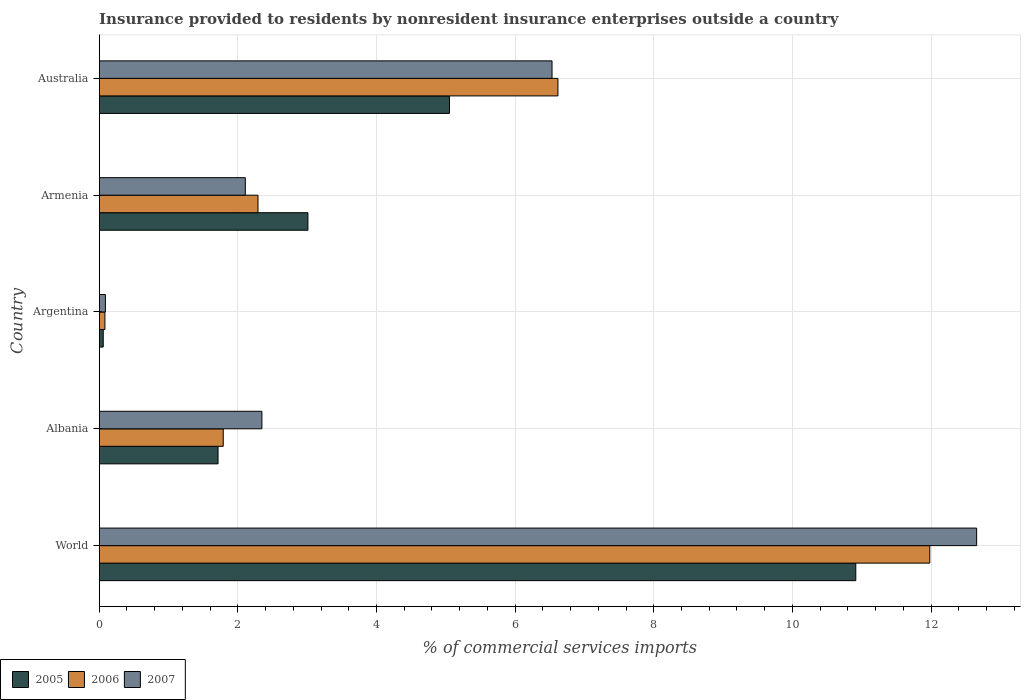How many bars are there on the 3rd tick from the bottom?
Ensure brevity in your answer.  3. What is the label of the 4th group of bars from the top?
Your answer should be compact. Albania. What is the Insurance provided to residents in 2005 in Albania?
Ensure brevity in your answer.  1.71. Across all countries, what is the maximum Insurance provided to residents in 2007?
Your response must be concise. 12.66. Across all countries, what is the minimum Insurance provided to residents in 2005?
Keep it short and to the point. 0.06. In which country was the Insurance provided to residents in 2005 maximum?
Provide a succinct answer. World. What is the total Insurance provided to residents in 2005 in the graph?
Your answer should be very brief. 20.75. What is the difference between the Insurance provided to residents in 2007 in Armenia and that in World?
Give a very brief answer. -10.55. What is the difference between the Insurance provided to residents in 2005 in Albania and the Insurance provided to residents in 2007 in World?
Provide a succinct answer. -10.94. What is the average Insurance provided to residents in 2005 per country?
Provide a succinct answer. 4.15. What is the difference between the Insurance provided to residents in 2005 and Insurance provided to residents in 2007 in Albania?
Provide a short and direct response. -0.63. In how many countries, is the Insurance provided to residents in 2007 greater than 4.8 %?
Your answer should be very brief. 2. What is the ratio of the Insurance provided to residents in 2007 in Argentina to that in Australia?
Ensure brevity in your answer.  0.01. What is the difference between the highest and the second highest Insurance provided to residents in 2005?
Give a very brief answer. 5.86. What is the difference between the highest and the lowest Insurance provided to residents in 2006?
Offer a very short reply. 11.9. In how many countries, is the Insurance provided to residents in 2006 greater than the average Insurance provided to residents in 2006 taken over all countries?
Keep it short and to the point. 2. Is the sum of the Insurance provided to residents in 2006 in Albania and Armenia greater than the maximum Insurance provided to residents in 2005 across all countries?
Give a very brief answer. No. What does the 1st bar from the bottom in World represents?
Ensure brevity in your answer.  2005. Is it the case that in every country, the sum of the Insurance provided to residents in 2006 and Insurance provided to residents in 2007 is greater than the Insurance provided to residents in 2005?
Keep it short and to the point. Yes. Does the graph contain grids?
Your response must be concise. Yes. Where does the legend appear in the graph?
Provide a short and direct response. Bottom left. How many legend labels are there?
Your answer should be compact. 3. How are the legend labels stacked?
Give a very brief answer. Horizontal. What is the title of the graph?
Your response must be concise. Insurance provided to residents by nonresident insurance enterprises outside a country. Does "2011" appear as one of the legend labels in the graph?
Your answer should be very brief. No. What is the label or title of the X-axis?
Offer a terse response. % of commercial services imports. What is the label or title of the Y-axis?
Make the answer very short. Country. What is the % of commercial services imports in 2005 in World?
Provide a short and direct response. 10.91. What is the % of commercial services imports in 2006 in World?
Provide a succinct answer. 11.98. What is the % of commercial services imports of 2007 in World?
Provide a short and direct response. 12.66. What is the % of commercial services imports in 2005 in Albania?
Keep it short and to the point. 1.71. What is the % of commercial services imports in 2006 in Albania?
Your response must be concise. 1.79. What is the % of commercial services imports in 2007 in Albania?
Your answer should be very brief. 2.35. What is the % of commercial services imports of 2005 in Argentina?
Keep it short and to the point. 0.06. What is the % of commercial services imports of 2006 in Argentina?
Ensure brevity in your answer.  0.08. What is the % of commercial services imports in 2007 in Argentina?
Your response must be concise. 0.09. What is the % of commercial services imports of 2005 in Armenia?
Make the answer very short. 3.01. What is the % of commercial services imports of 2006 in Armenia?
Provide a short and direct response. 2.29. What is the % of commercial services imports in 2007 in Armenia?
Offer a terse response. 2.11. What is the % of commercial services imports of 2005 in Australia?
Provide a succinct answer. 5.05. What is the % of commercial services imports in 2006 in Australia?
Your response must be concise. 6.62. What is the % of commercial services imports in 2007 in Australia?
Your answer should be compact. 6.53. Across all countries, what is the maximum % of commercial services imports of 2005?
Offer a very short reply. 10.91. Across all countries, what is the maximum % of commercial services imports in 2006?
Keep it short and to the point. 11.98. Across all countries, what is the maximum % of commercial services imports in 2007?
Make the answer very short. 12.66. Across all countries, what is the minimum % of commercial services imports of 2005?
Ensure brevity in your answer.  0.06. Across all countries, what is the minimum % of commercial services imports of 2006?
Your answer should be very brief. 0.08. Across all countries, what is the minimum % of commercial services imports in 2007?
Your answer should be compact. 0.09. What is the total % of commercial services imports in 2005 in the graph?
Provide a short and direct response. 20.75. What is the total % of commercial services imports in 2006 in the graph?
Offer a terse response. 22.76. What is the total % of commercial services imports of 2007 in the graph?
Your answer should be very brief. 23.73. What is the difference between the % of commercial services imports in 2005 in World and that in Albania?
Give a very brief answer. 9.2. What is the difference between the % of commercial services imports in 2006 in World and that in Albania?
Offer a terse response. 10.19. What is the difference between the % of commercial services imports in 2007 in World and that in Albania?
Give a very brief answer. 10.31. What is the difference between the % of commercial services imports of 2005 in World and that in Argentina?
Keep it short and to the point. 10.86. What is the difference between the % of commercial services imports in 2006 in World and that in Argentina?
Make the answer very short. 11.9. What is the difference between the % of commercial services imports in 2007 in World and that in Argentina?
Offer a terse response. 12.57. What is the difference between the % of commercial services imports in 2005 in World and that in Armenia?
Your answer should be compact. 7.9. What is the difference between the % of commercial services imports in 2006 in World and that in Armenia?
Your answer should be compact. 9.69. What is the difference between the % of commercial services imports of 2007 in World and that in Armenia?
Your response must be concise. 10.55. What is the difference between the % of commercial services imports of 2005 in World and that in Australia?
Keep it short and to the point. 5.86. What is the difference between the % of commercial services imports in 2006 in World and that in Australia?
Provide a short and direct response. 5.36. What is the difference between the % of commercial services imports of 2007 in World and that in Australia?
Ensure brevity in your answer.  6.13. What is the difference between the % of commercial services imports of 2005 in Albania and that in Argentina?
Give a very brief answer. 1.66. What is the difference between the % of commercial services imports in 2006 in Albania and that in Argentina?
Your response must be concise. 1.71. What is the difference between the % of commercial services imports of 2007 in Albania and that in Argentina?
Offer a very short reply. 2.26. What is the difference between the % of commercial services imports of 2005 in Albania and that in Armenia?
Provide a short and direct response. -1.3. What is the difference between the % of commercial services imports in 2006 in Albania and that in Armenia?
Your answer should be compact. -0.5. What is the difference between the % of commercial services imports in 2007 in Albania and that in Armenia?
Make the answer very short. 0.24. What is the difference between the % of commercial services imports of 2005 in Albania and that in Australia?
Make the answer very short. -3.34. What is the difference between the % of commercial services imports of 2006 in Albania and that in Australia?
Provide a short and direct response. -4.83. What is the difference between the % of commercial services imports of 2007 in Albania and that in Australia?
Your response must be concise. -4.19. What is the difference between the % of commercial services imports of 2005 in Argentina and that in Armenia?
Ensure brevity in your answer.  -2.95. What is the difference between the % of commercial services imports in 2006 in Argentina and that in Armenia?
Offer a terse response. -2.21. What is the difference between the % of commercial services imports in 2007 in Argentina and that in Armenia?
Your answer should be very brief. -2.02. What is the difference between the % of commercial services imports of 2005 in Argentina and that in Australia?
Give a very brief answer. -5. What is the difference between the % of commercial services imports of 2006 in Argentina and that in Australia?
Ensure brevity in your answer.  -6.54. What is the difference between the % of commercial services imports in 2007 in Argentina and that in Australia?
Provide a short and direct response. -6.44. What is the difference between the % of commercial services imports in 2005 in Armenia and that in Australia?
Offer a very short reply. -2.04. What is the difference between the % of commercial services imports of 2006 in Armenia and that in Australia?
Your response must be concise. -4.33. What is the difference between the % of commercial services imports in 2007 in Armenia and that in Australia?
Make the answer very short. -4.42. What is the difference between the % of commercial services imports of 2005 in World and the % of commercial services imports of 2006 in Albania?
Your answer should be very brief. 9.13. What is the difference between the % of commercial services imports in 2005 in World and the % of commercial services imports in 2007 in Albania?
Offer a terse response. 8.57. What is the difference between the % of commercial services imports of 2006 in World and the % of commercial services imports of 2007 in Albania?
Give a very brief answer. 9.63. What is the difference between the % of commercial services imports of 2005 in World and the % of commercial services imports of 2006 in Argentina?
Your answer should be very brief. 10.83. What is the difference between the % of commercial services imports in 2005 in World and the % of commercial services imports in 2007 in Argentina?
Your answer should be very brief. 10.83. What is the difference between the % of commercial services imports of 2006 in World and the % of commercial services imports of 2007 in Argentina?
Ensure brevity in your answer.  11.89. What is the difference between the % of commercial services imports of 2005 in World and the % of commercial services imports of 2006 in Armenia?
Keep it short and to the point. 8.62. What is the difference between the % of commercial services imports of 2005 in World and the % of commercial services imports of 2007 in Armenia?
Make the answer very short. 8.81. What is the difference between the % of commercial services imports in 2006 in World and the % of commercial services imports in 2007 in Armenia?
Make the answer very short. 9.87. What is the difference between the % of commercial services imports in 2005 in World and the % of commercial services imports in 2006 in Australia?
Make the answer very short. 4.3. What is the difference between the % of commercial services imports in 2005 in World and the % of commercial services imports in 2007 in Australia?
Provide a succinct answer. 4.38. What is the difference between the % of commercial services imports in 2006 in World and the % of commercial services imports in 2007 in Australia?
Give a very brief answer. 5.45. What is the difference between the % of commercial services imports of 2005 in Albania and the % of commercial services imports of 2006 in Argentina?
Keep it short and to the point. 1.63. What is the difference between the % of commercial services imports of 2005 in Albania and the % of commercial services imports of 2007 in Argentina?
Keep it short and to the point. 1.63. What is the difference between the % of commercial services imports of 2006 in Albania and the % of commercial services imports of 2007 in Argentina?
Keep it short and to the point. 1.7. What is the difference between the % of commercial services imports in 2005 in Albania and the % of commercial services imports in 2006 in Armenia?
Provide a succinct answer. -0.58. What is the difference between the % of commercial services imports in 2005 in Albania and the % of commercial services imports in 2007 in Armenia?
Provide a succinct answer. -0.39. What is the difference between the % of commercial services imports in 2006 in Albania and the % of commercial services imports in 2007 in Armenia?
Ensure brevity in your answer.  -0.32. What is the difference between the % of commercial services imports in 2005 in Albania and the % of commercial services imports in 2006 in Australia?
Provide a succinct answer. -4.9. What is the difference between the % of commercial services imports of 2005 in Albania and the % of commercial services imports of 2007 in Australia?
Make the answer very short. -4.82. What is the difference between the % of commercial services imports in 2006 in Albania and the % of commercial services imports in 2007 in Australia?
Provide a short and direct response. -4.74. What is the difference between the % of commercial services imports of 2005 in Argentina and the % of commercial services imports of 2006 in Armenia?
Your answer should be compact. -2.23. What is the difference between the % of commercial services imports in 2005 in Argentina and the % of commercial services imports in 2007 in Armenia?
Offer a terse response. -2.05. What is the difference between the % of commercial services imports of 2006 in Argentina and the % of commercial services imports of 2007 in Armenia?
Offer a terse response. -2.03. What is the difference between the % of commercial services imports of 2005 in Argentina and the % of commercial services imports of 2006 in Australia?
Give a very brief answer. -6.56. What is the difference between the % of commercial services imports in 2005 in Argentina and the % of commercial services imports in 2007 in Australia?
Keep it short and to the point. -6.47. What is the difference between the % of commercial services imports in 2006 in Argentina and the % of commercial services imports in 2007 in Australia?
Your response must be concise. -6.45. What is the difference between the % of commercial services imports in 2005 in Armenia and the % of commercial services imports in 2006 in Australia?
Keep it short and to the point. -3.61. What is the difference between the % of commercial services imports of 2005 in Armenia and the % of commercial services imports of 2007 in Australia?
Ensure brevity in your answer.  -3.52. What is the difference between the % of commercial services imports of 2006 in Armenia and the % of commercial services imports of 2007 in Australia?
Offer a very short reply. -4.24. What is the average % of commercial services imports in 2005 per country?
Your answer should be very brief. 4.15. What is the average % of commercial services imports of 2006 per country?
Offer a very short reply. 4.55. What is the average % of commercial services imports in 2007 per country?
Your answer should be compact. 4.75. What is the difference between the % of commercial services imports of 2005 and % of commercial services imports of 2006 in World?
Offer a terse response. -1.07. What is the difference between the % of commercial services imports in 2005 and % of commercial services imports in 2007 in World?
Keep it short and to the point. -1.74. What is the difference between the % of commercial services imports in 2006 and % of commercial services imports in 2007 in World?
Keep it short and to the point. -0.68. What is the difference between the % of commercial services imports of 2005 and % of commercial services imports of 2006 in Albania?
Your answer should be very brief. -0.07. What is the difference between the % of commercial services imports in 2005 and % of commercial services imports in 2007 in Albania?
Your response must be concise. -0.63. What is the difference between the % of commercial services imports of 2006 and % of commercial services imports of 2007 in Albania?
Provide a succinct answer. -0.56. What is the difference between the % of commercial services imports of 2005 and % of commercial services imports of 2006 in Argentina?
Keep it short and to the point. -0.02. What is the difference between the % of commercial services imports in 2005 and % of commercial services imports in 2007 in Argentina?
Keep it short and to the point. -0.03. What is the difference between the % of commercial services imports of 2006 and % of commercial services imports of 2007 in Argentina?
Give a very brief answer. -0.01. What is the difference between the % of commercial services imports in 2005 and % of commercial services imports in 2006 in Armenia?
Your response must be concise. 0.72. What is the difference between the % of commercial services imports of 2005 and % of commercial services imports of 2007 in Armenia?
Give a very brief answer. 0.9. What is the difference between the % of commercial services imports in 2006 and % of commercial services imports in 2007 in Armenia?
Your answer should be compact. 0.18. What is the difference between the % of commercial services imports of 2005 and % of commercial services imports of 2006 in Australia?
Make the answer very short. -1.56. What is the difference between the % of commercial services imports of 2005 and % of commercial services imports of 2007 in Australia?
Your answer should be very brief. -1.48. What is the difference between the % of commercial services imports of 2006 and % of commercial services imports of 2007 in Australia?
Offer a very short reply. 0.09. What is the ratio of the % of commercial services imports of 2005 in World to that in Albania?
Make the answer very short. 6.37. What is the ratio of the % of commercial services imports in 2006 in World to that in Albania?
Ensure brevity in your answer.  6.7. What is the ratio of the % of commercial services imports of 2007 in World to that in Albania?
Offer a very short reply. 5.39. What is the ratio of the % of commercial services imports in 2005 in World to that in Argentina?
Ensure brevity in your answer.  188.47. What is the ratio of the % of commercial services imports in 2006 in World to that in Argentina?
Give a very brief answer. 145.59. What is the ratio of the % of commercial services imports of 2007 in World to that in Argentina?
Ensure brevity in your answer.  142.09. What is the ratio of the % of commercial services imports in 2005 in World to that in Armenia?
Provide a succinct answer. 3.63. What is the ratio of the % of commercial services imports of 2006 in World to that in Armenia?
Ensure brevity in your answer.  5.23. What is the ratio of the % of commercial services imports in 2007 in World to that in Armenia?
Your answer should be compact. 6.01. What is the ratio of the % of commercial services imports of 2005 in World to that in Australia?
Your answer should be very brief. 2.16. What is the ratio of the % of commercial services imports in 2006 in World to that in Australia?
Offer a very short reply. 1.81. What is the ratio of the % of commercial services imports of 2007 in World to that in Australia?
Offer a very short reply. 1.94. What is the ratio of the % of commercial services imports of 2005 in Albania to that in Argentina?
Keep it short and to the point. 29.6. What is the ratio of the % of commercial services imports of 2006 in Albania to that in Argentina?
Your answer should be very brief. 21.74. What is the ratio of the % of commercial services imports in 2007 in Albania to that in Argentina?
Offer a very short reply. 26.34. What is the ratio of the % of commercial services imports in 2005 in Albania to that in Armenia?
Your answer should be compact. 0.57. What is the ratio of the % of commercial services imports in 2006 in Albania to that in Armenia?
Offer a very short reply. 0.78. What is the ratio of the % of commercial services imports of 2007 in Albania to that in Armenia?
Provide a short and direct response. 1.11. What is the ratio of the % of commercial services imports of 2005 in Albania to that in Australia?
Offer a very short reply. 0.34. What is the ratio of the % of commercial services imports of 2006 in Albania to that in Australia?
Offer a very short reply. 0.27. What is the ratio of the % of commercial services imports in 2007 in Albania to that in Australia?
Keep it short and to the point. 0.36. What is the ratio of the % of commercial services imports of 2005 in Argentina to that in Armenia?
Ensure brevity in your answer.  0.02. What is the ratio of the % of commercial services imports of 2006 in Argentina to that in Armenia?
Make the answer very short. 0.04. What is the ratio of the % of commercial services imports of 2007 in Argentina to that in Armenia?
Your answer should be compact. 0.04. What is the ratio of the % of commercial services imports of 2005 in Argentina to that in Australia?
Make the answer very short. 0.01. What is the ratio of the % of commercial services imports in 2006 in Argentina to that in Australia?
Provide a succinct answer. 0.01. What is the ratio of the % of commercial services imports in 2007 in Argentina to that in Australia?
Your answer should be compact. 0.01. What is the ratio of the % of commercial services imports in 2005 in Armenia to that in Australia?
Make the answer very short. 0.6. What is the ratio of the % of commercial services imports in 2006 in Armenia to that in Australia?
Give a very brief answer. 0.35. What is the ratio of the % of commercial services imports of 2007 in Armenia to that in Australia?
Make the answer very short. 0.32. What is the difference between the highest and the second highest % of commercial services imports in 2005?
Make the answer very short. 5.86. What is the difference between the highest and the second highest % of commercial services imports of 2006?
Keep it short and to the point. 5.36. What is the difference between the highest and the second highest % of commercial services imports of 2007?
Provide a succinct answer. 6.13. What is the difference between the highest and the lowest % of commercial services imports in 2005?
Offer a terse response. 10.86. What is the difference between the highest and the lowest % of commercial services imports in 2006?
Your answer should be compact. 11.9. What is the difference between the highest and the lowest % of commercial services imports of 2007?
Give a very brief answer. 12.57. 